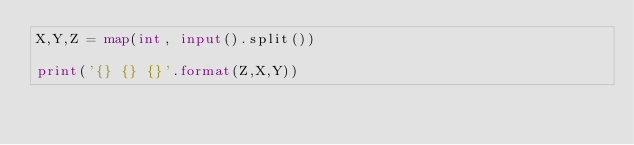Convert code to text. <code><loc_0><loc_0><loc_500><loc_500><_Python_>X,Y,Z = map(int, input().split())

print('{} {} {}'.format(Z,X,Y))</code> 